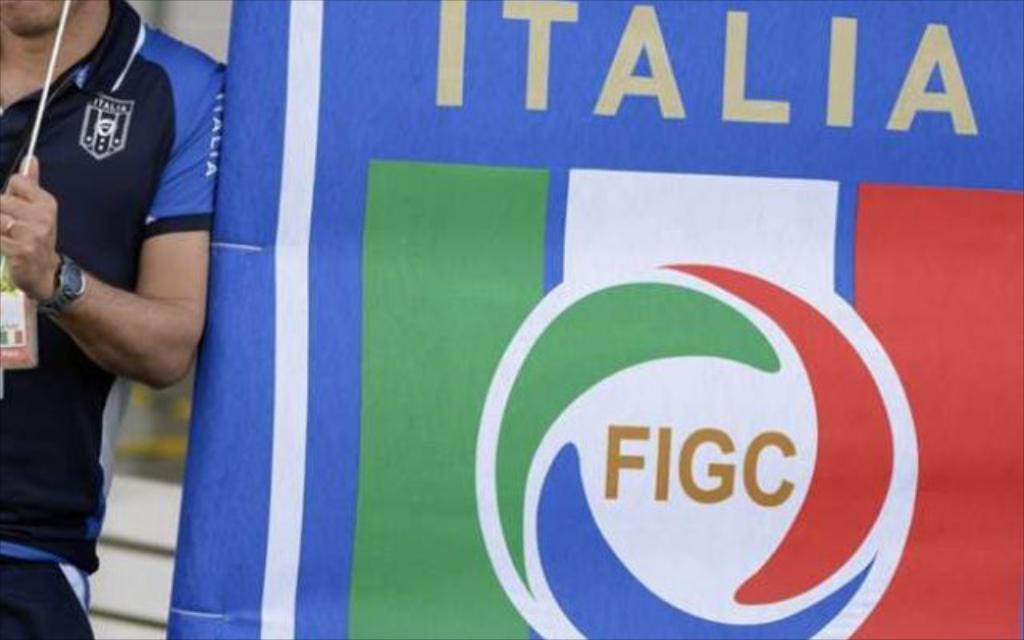Could you give a brief overview of what you see in this image? In the image there is a person standing beside a football banner and holding a stick in his hand, there is a watch to his hand and he is also wearing ID card. 